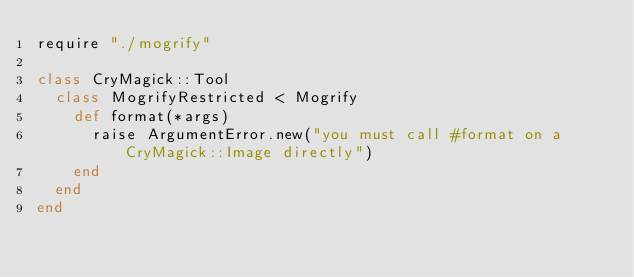<code> <loc_0><loc_0><loc_500><loc_500><_Crystal_>require "./mogrify"

class CryMagick::Tool
  class MogrifyRestricted < Mogrify
    def format(*args)
      raise ArgumentError.new("you must call #format on a CryMagick::Image directly")
    end
  end
end
</code> 